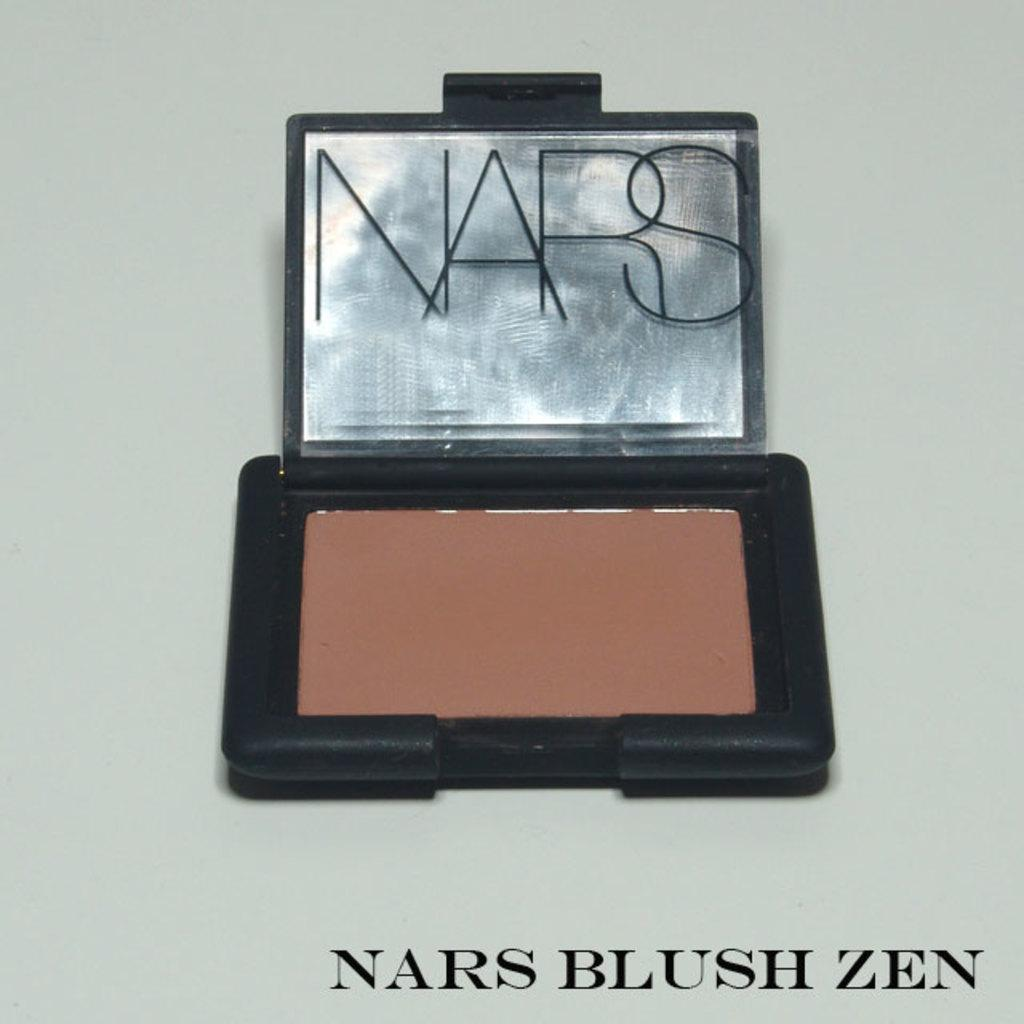<image>
Present a compact description of the photo's key features. An open compact of Nars blush zen with a mirror 